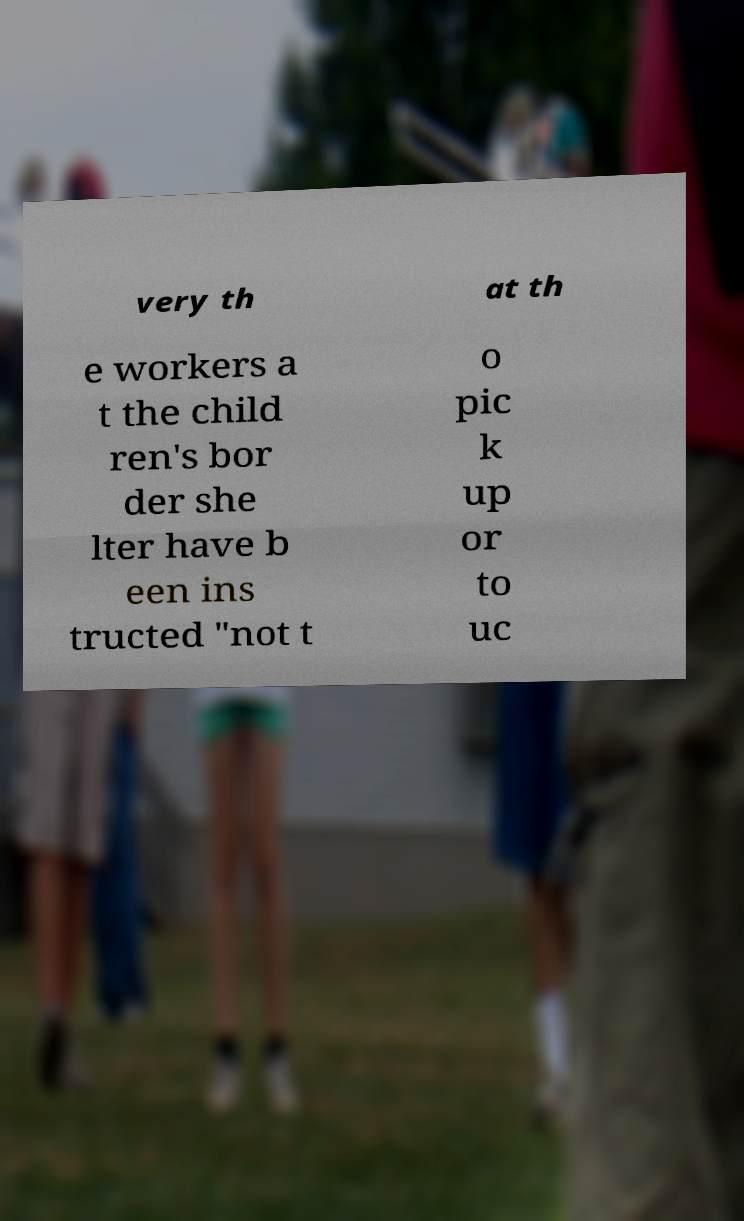There's text embedded in this image that I need extracted. Can you transcribe it verbatim? very th at th e workers a t the child ren's bor der she lter have b een ins tructed "not t o pic k up or to uc 